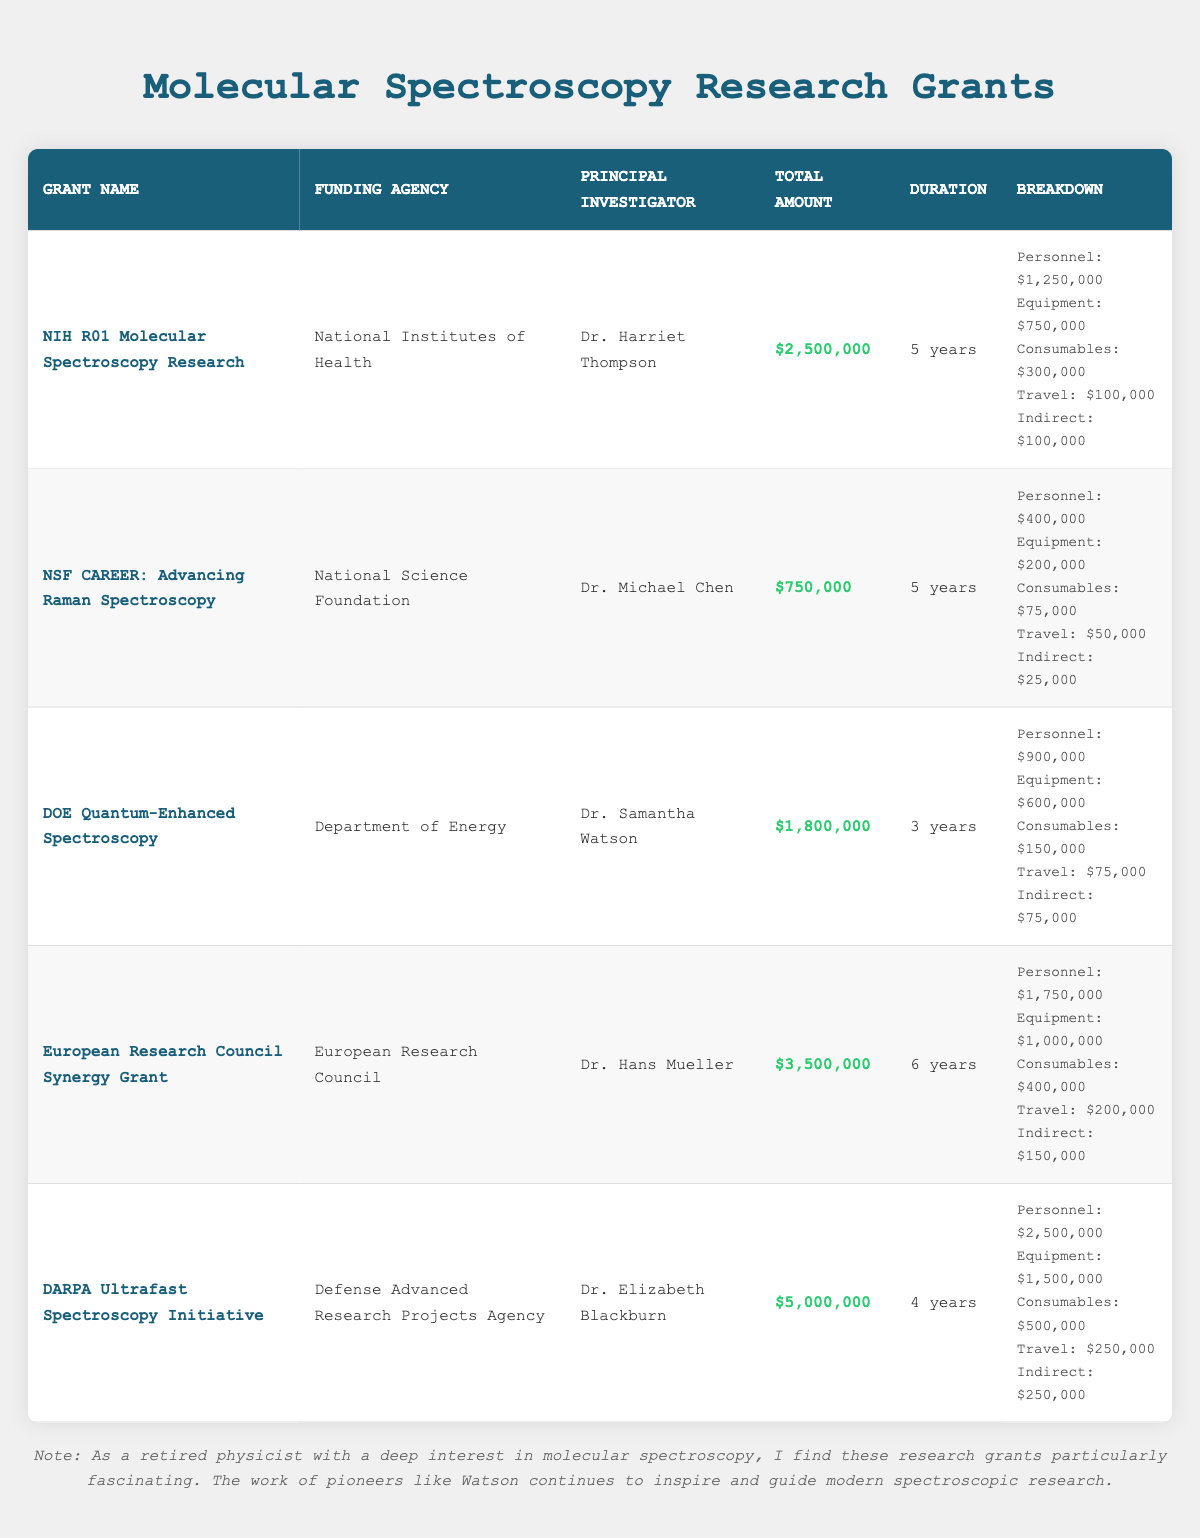What is the total amount of the NIH R01 Molecular Spectroscopy Research grant? The table indicates that the total amount of the NIH R01 Molecular Spectroscopy Research grant is explicitly stated in the corresponding row.
Answer: 2,500,000 Which funding agency supports the DARPA Ultrafast Spectroscopy Initiative? By looking at the row for the DARPA Ultrafast Spectroscopy Initiative, it is clear that the funding agency is specified in that row.
Answer: Defense Advanced Research Projects Agency What is the duration of the DOE Quantum-Enhanced Spectroscopy grant? The duration is mentioned in the row dedicated to the DOE Quantum-Enhanced Spectroscopy grant.
Answer: 3 years Which project has the highest personnel costs? Reviewing the personnel costs listed in each row, the DARPA Ultrafast Spectroscopy Initiative has the highest at 2,500,000. This is determined by comparing the personnel costs across all grants.
Answer: DARPA Ultrafast Spectroscopy Initiative What is the total funding amount for the European Research Council Synergy Grant and the NSF CAREER grant combined? To find the total, add the funding amount of the European Research Council Synergy Grant (3,500,000) to that of the NSF CAREER grant (750,000). The calculation is 3,500,000 + 750,000 = 4,250,000.
Answer: 4,250,000 Is the travel and conferences cost for the NIH R01 grant greater than that for the NSF CAREER grant? Comparing the travel and conferences costs from both grants, the NIH R01 grant has a cost of 100,000 while the NSF CAREER grant has a cost of 50,000. Since 100,000 is greater than 50,000, the statement is true.
Answer: Yes What is the average total funding amount of the grants listed? First, sum all total amounts: 2,500,000 + 750,000 + 1,800,000 + 3,500,000 + 5,000,000 = 13,550,000. Since there are 5 grants, divide the total by 5, which results in 13,550,000 / 5 = 2,710,000.
Answer: 2,710,000 Is Dr. Harriet Thompson the principal investigator with the highest funding amount? Checking the total funding amount associated with Dr. Harriet Thompson's grant (2,500,000), and comparing it to the others reveals that Dr. Elizabeth Blackburn has a higher funding amount (5,000,000), making this statement false.
Answer: No What are the indirect costs for the European Research Council Synergy Grant? The indirect costs are clearly mentioned under the breakdown section of the European Research Council Synergy Grant row.
Answer: 150,000 